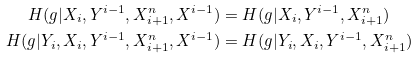Convert formula to latex. <formula><loc_0><loc_0><loc_500><loc_500>H ( g | X _ { i } , Y ^ { i - 1 } , X _ { i + 1 } ^ { n } , X ^ { i - 1 } ) & = H ( g | X _ { i } , Y ^ { i - 1 } , X _ { i + 1 } ^ { n } ) \\ H ( g | Y _ { i } , X _ { i } , Y ^ { i - 1 } , X _ { i + 1 } ^ { n } , X ^ { i - 1 } ) & = H ( g | Y _ { i } , X _ { i } , Y ^ { i - 1 } , X _ { i + 1 } ^ { n } )</formula> 